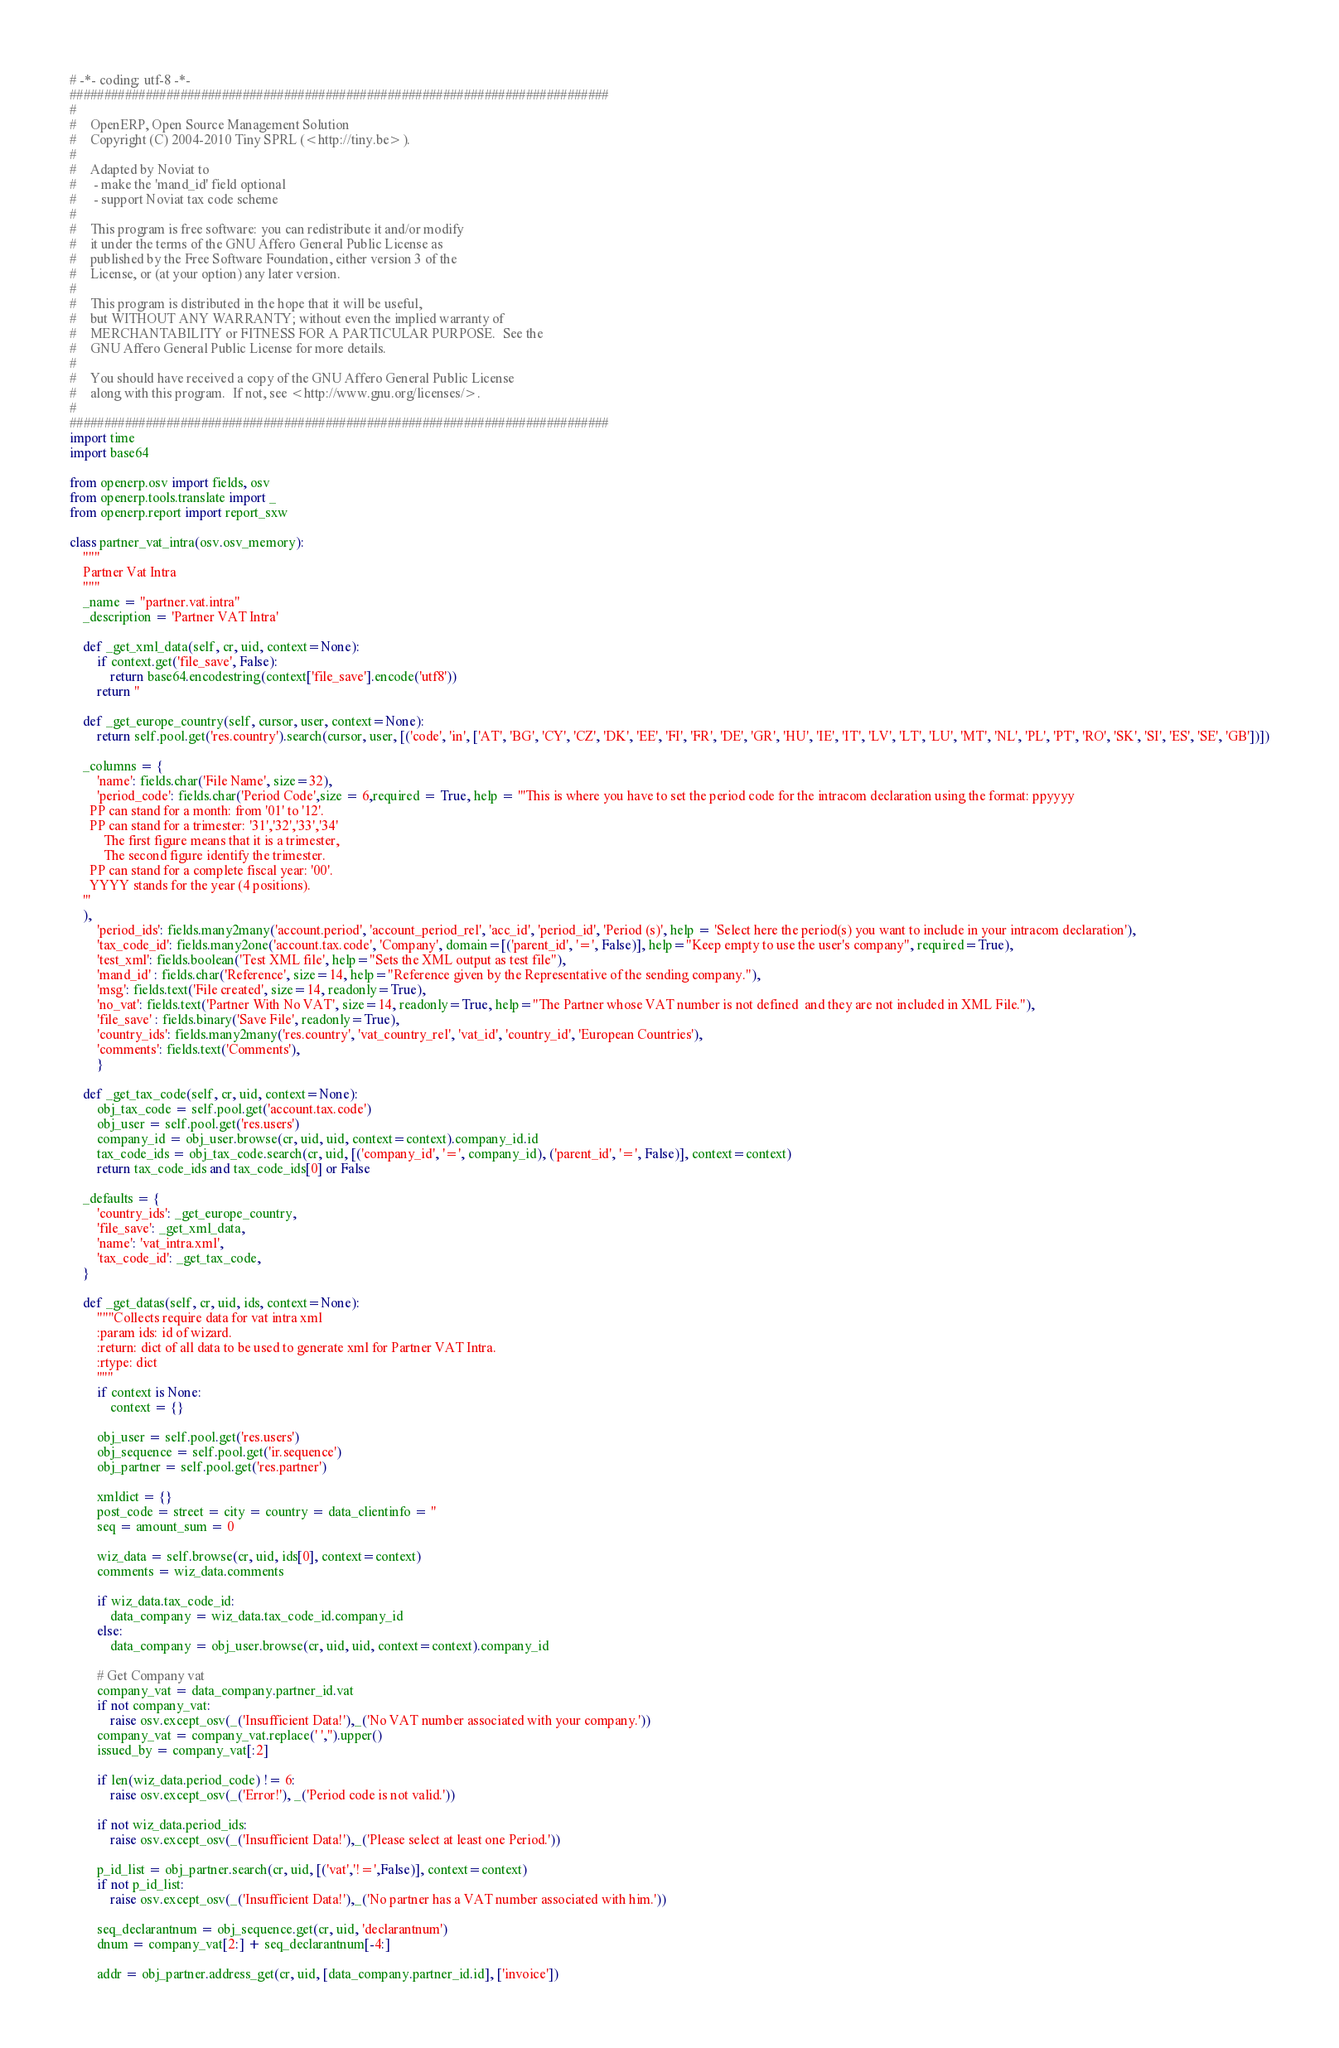<code> <loc_0><loc_0><loc_500><loc_500><_Python_># -*- coding: utf-8 -*-
##############################################################################
#
#    OpenERP, Open Source Management Solution
#    Copyright (C) 2004-2010 Tiny SPRL (<http://tiny.be>).
#
#    Adapted by Noviat to
#     - make the 'mand_id' field optional
#     - support Noviat tax code scheme
#
#    This program is free software: you can redistribute it and/or modify
#    it under the terms of the GNU Affero General Public License as
#    published by the Free Software Foundation, either version 3 of the
#    License, or (at your option) any later version.
#
#    This program is distributed in the hope that it will be useful,
#    but WITHOUT ANY WARRANTY; without even the implied warranty of
#    MERCHANTABILITY or FITNESS FOR A PARTICULAR PURPOSE.  See the
#    GNU Affero General Public License for more details.
#
#    You should have received a copy of the GNU Affero General Public License
#    along with this program.  If not, see <http://www.gnu.org/licenses/>.
#
##############################################################################
import time
import base64

from openerp.osv import fields, osv
from openerp.tools.translate import _
from openerp.report import report_sxw

class partner_vat_intra(osv.osv_memory):
    """
    Partner Vat Intra
    """
    _name = "partner.vat.intra"
    _description = 'Partner VAT Intra'

    def _get_xml_data(self, cr, uid, context=None):
        if context.get('file_save', False):
            return base64.encodestring(context['file_save'].encode('utf8'))
        return ''

    def _get_europe_country(self, cursor, user, context=None):
        return self.pool.get('res.country').search(cursor, user, [('code', 'in', ['AT', 'BG', 'CY', 'CZ', 'DK', 'EE', 'FI', 'FR', 'DE', 'GR', 'HU', 'IE', 'IT', 'LV', 'LT', 'LU', 'MT', 'NL', 'PL', 'PT', 'RO', 'SK', 'SI', 'ES', 'SE', 'GB'])])

    _columns = {
        'name': fields.char('File Name', size=32),
        'period_code': fields.char('Period Code',size = 6,required = True, help = '''This is where you have to set the period code for the intracom declaration using the format: ppyyyy
      PP can stand for a month: from '01' to '12'.
      PP can stand for a trimester: '31','32','33','34'
          The first figure means that it is a trimester,
          The second figure identify the trimester.
      PP can stand for a complete fiscal year: '00'.
      YYYY stands for the year (4 positions).
    '''
    ),
        'period_ids': fields.many2many('account.period', 'account_period_rel', 'acc_id', 'period_id', 'Period (s)', help = 'Select here the period(s) you want to include in your intracom declaration'),
        'tax_code_id': fields.many2one('account.tax.code', 'Company', domain=[('parent_id', '=', False)], help="Keep empty to use the user's company", required=True),
        'test_xml': fields.boolean('Test XML file', help="Sets the XML output as test file"),
        'mand_id' : fields.char('Reference', size=14, help="Reference given by the Representative of the sending company."),
        'msg': fields.text('File created', size=14, readonly=True),
        'no_vat': fields.text('Partner With No VAT', size=14, readonly=True, help="The Partner whose VAT number is not defined  and they are not included in XML File."),
        'file_save' : fields.binary('Save File', readonly=True),
        'country_ids': fields.many2many('res.country', 'vat_country_rel', 'vat_id', 'country_id', 'European Countries'),
        'comments': fields.text('Comments'),
        }

    def _get_tax_code(self, cr, uid, context=None):
        obj_tax_code = self.pool.get('account.tax.code')
        obj_user = self.pool.get('res.users')
        company_id = obj_user.browse(cr, uid, uid, context=context).company_id.id
        tax_code_ids = obj_tax_code.search(cr, uid, [('company_id', '=', company_id), ('parent_id', '=', False)], context=context)
        return tax_code_ids and tax_code_ids[0] or False

    _defaults = {
        'country_ids': _get_europe_country,
        'file_save': _get_xml_data,
        'name': 'vat_intra.xml',
        'tax_code_id': _get_tax_code,
    }

    def _get_datas(self, cr, uid, ids, context=None):
        """Collects require data for vat intra xml
        :param ids: id of wizard.
        :return: dict of all data to be used to generate xml for Partner VAT Intra.
        :rtype: dict
        """
        if context is None:
            context = {}

        obj_user = self.pool.get('res.users')
        obj_sequence = self.pool.get('ir.sequence')
        obj_partner = self.pool.get('res.partner')

        xmldict = {}
        post_code = street = city = country = data_clientinfo = ''
        seq = amount_sum = 0

        wiz_data = self.browse(cr, uid, ids[0], context=context)
        comments = wiz_data.comments

        if wiz_data.tax_code_id:
            data_company = wiz_data.tax_code_id.company_id
        else:
            data_company = obj_user.browse(cr, uid, uid, context=context).company_id

        # Get Company vat
        company_vat = data_company.partner_id.vat
        if not company_vat:
            raise osv.except_osv(_('Insufficient Data!'),_('No VAT number associated with your company.'))
        company_vat = company_vat.replace(' ','').upper()
        issued_by = company_vat[:2]

        if len(wiz_data.period_code) != 6:
            raise osv.except_osv(_('Error!'), _('Period code is not valid.'))

        if not wiz_data.period_ids:
            raise osv.except_osv(_('Insufficient Data!'),_('Please select at least one Period.'))

        p_id_list = obj_partner.search(cr, uid, [('vat','!=',False)], context=context)
        if not p_id_list:
            raise osv.except_osv(_('Insufficient Data!'),_('No partner has a VAT number associated with him.'))

        seq_declarantnum = obj_sequence.get(cr, uid, 'declarantnum')
        dnum = company_vat[2:] + seq_declarantnum[-4:]

        addr = obj_partner.address_get(cr, uid, [data_company.partner_id.id], ['invoice'])</code> 